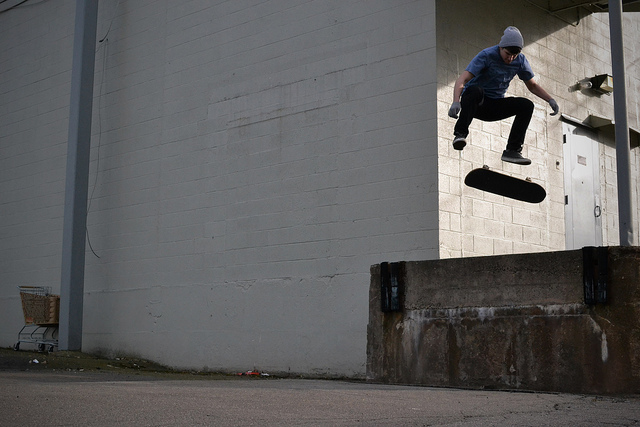<image>What is present? It is ambiguous what is present in the image. It could be a skateboarder, a person, a shopping cart, or a combination of these items. What is present? I am not sure what is present in the image. It can be seen a male person, skateboard, and shopping cart. 